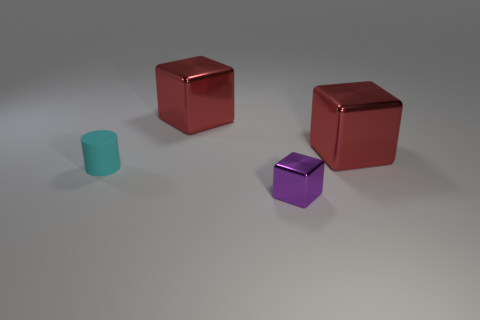Add 4 purple blocks. How many objects exist? 8 Subtract all cubes. How many objects are left? 1 Add 4 small purple things. How many small purple things are left? 5 Add 1 big metallic cylinders. How many big metallic cylinders exist? 1 Subtract 1 purple blocks. How many objects are left? 3 Subtract all large red spheres. Subtract all cyan matte things. How many objects are left? 3 